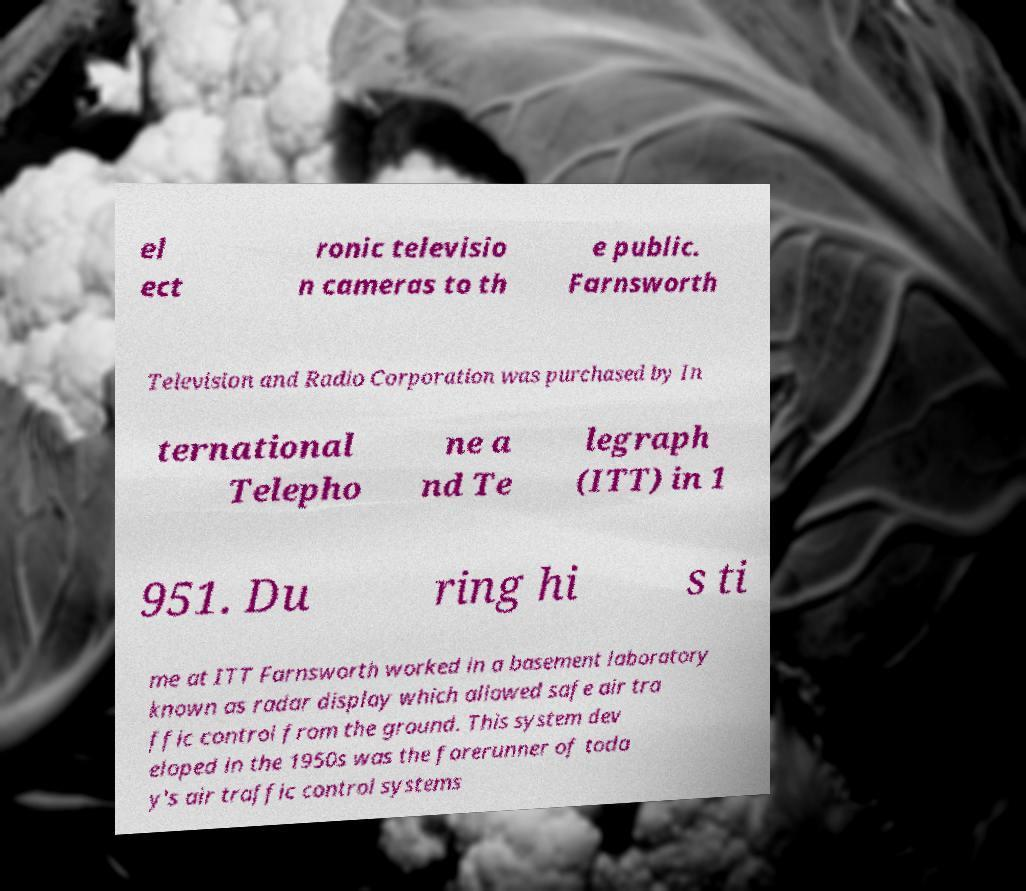What messages or text are displayed in this image? I need them in a readable, typed format. el ect ronic televisio n cameras to th e public. Farnsworth Television and Radio Corporation was purchased by In ternational Telepho ne a nd Te legraph (ITT) in 1 951. Du ring hi s ti me at ITT Farnsworth worked in a basement laboratory known as radar display which allowed safe air tra ffic control from the ground. This system dev eloped in the 1950s was the forerunner of toda y's air traffic control systems 